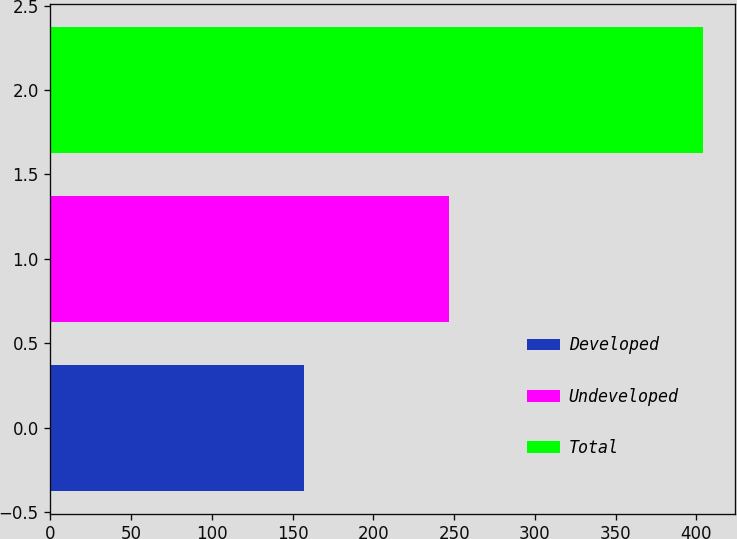Convert chart. <chart><loc_0><loc_0><loc_500><loc_500><bar_chart><fcel>Developed<fcel>Undeveloped<fcel>Total<nl><fcel>157<fcel>247<fcel>404<nl></chart> 